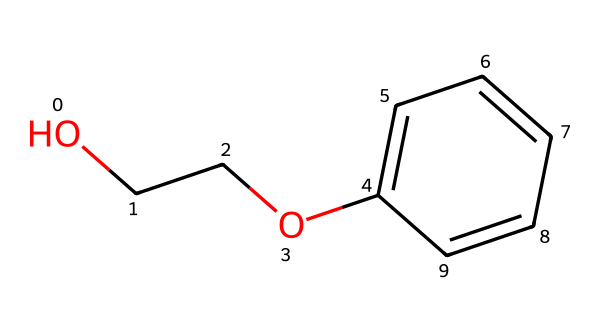What is the molecular formula of phenoxyethanol? To determine the molecular formula, count all carbon (C), hydrogen (H), and oxygen (O) atoms in the structure. The molecule has 8 carbons, 10 hydrogens, and 2 oxygens, leading to the formula C8H10O2.
Answer: C8H10O2 How many carbon atoms are present in this compound? By examining the structure, there are a total of 8 carbon atoms visible in the SMILES representation.
Answer: 8 What is the functional group present in phenoxyethanol? The presence of the ether (-O-) between two carbon chains and the hydroxyl (-OH) group indicates that this compound contains alcohol and ether functional groups.
Answer: ether, alcohol Is phenoxyethanol a preservative? Phenoxyethanol is commonly used as a preservative in cosmetics and skincare products to prevent microbial growth.
Answer: Yes What is the boiling point of phenoxyethanol? Research indicates that phenoxyethanol has a boiling point of approximately 172 °C, based on its structural characteristics and known data.
Answer: 172 °C Does phenoxyethanol have any aromatic rings? The presence of the benzene ring (C1=CC=CC=C1) in the chemical structure indicates that it contains an aromatic ring.
Answer: Yes What is the primary use of phenoxyethanol in dermatological formulations? The primary use of phenoxyethanol in dermatological formulations is as a preservative to extend shelf life and prevent bacterial growth.
Answer: preservative 